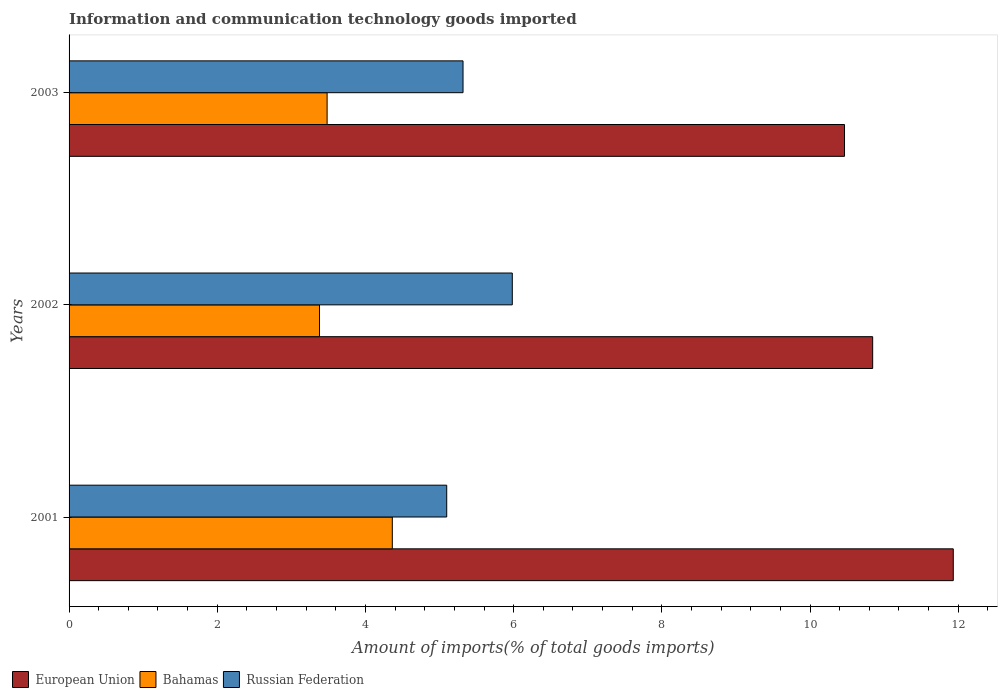How many different coloured bars are there?
Offer a terse response. 3. Are the number of bars on each tick of the Y-axis equal?
Ensure brevity in your answer.  Yes. How many bars are there on the 3rd tick from the bottom?
Your response must be concise. 3. What is the label of the 3rd group of bars from the top?
Give a very brief answer. 2001. What is the amount of goods imported in Bahamas in 2002?
Your answer should be very brief. 3.38. Across all years, what is the maximum amount of goods imported in Russian Federation?
Offer a very short reply. 5.98. Across all years, what is the minimum amount of goods imported in European Union?
Provide a short and direct response. 10.47. In which year was the amount of goods imported in Russian Federation maximum?
Your answer should be very brief. 2002. In which year was the amount of goods imported in Bahamas minimum?
Your answer should be very brief. 2002. What is the total amount of goods imported in European Union in the graph?
Your answer should be very brief. 33.25. What is the difference between the amount of goods imported in European Union in 2001 and that in 2002?
Your answer should be compact. 1.09. What is the difference between the amount of goods imported in European Union in 2001 and the amount of goods imported in Russian Federation in 2002?
Offer a very short reply. 5.95. What is the average amount of goods imported in European Union per year?
Offer a terse response. 11.08. In the year 2001, what is the difference between the amount of goods imported in European Union and amount of goods imported in Russian Federation?
Your answer should be compact. 6.84. What is the ratio of the amount of goods imported in Bahamas in 2002 to that in 2003?
Your response must be concise. 0.97. Is the amount of goods imported in Bahamas in 2001 less than that in 2003?
Give a very brief answer. No. What is the difference between the highest and the second highest amount of goods imported in Bahamas?
Your answer should be very brief. 0.88. What is the difference between the highest and the lowest amount of goods imported in Russian Federation?
Your answer should be compact. 0.89. Is the sum of the amount of goods imported in Bahamas in 2001 and 2003 greater than the maximum amount of goods imported in Russian Federation across all years?
Your answer should be very brief. Yes. What does the 1st bar from the top in 2003 represents?
Keep it short and to the point. Russian Federation. What does the 2nd bar from the bottom in 2003 represents?
Offer a very short reply. Bahamas. Is it the case that in every year, the sum of the amount of goods imported in Russian Federation and amount of goods imported in Bahamas is greater than the amount of goods imported in European Union?
Your response must be concise. No. Does the graph contain grids?
Ensure brevity in your answer.  No. Where does the legend appear in the graph?
Provide a succinct answer. Bottom left. How are the legend labels stacked?
Ensure brevity in your answer.  Horizontal. What is the title of the graph?
Provide a short and direct response. Information and communication technology goods imported. What is the label or title of the X-axis?
Ensure brevity in your answer.  Amount of imports(% of total goods imports). What is the label or title of the Y-axis?
Offer a terse response. Years. What is the Amount of imports(% of total goods imports) of European Union in 2001?
Your answer should be compact. 11.93. What is the Amount of imports(% of total goods imports) in Bahamas in 2001?
Your response must be concise. 4.36. What is the Amount of imports(% of total goods imports) of Russian Federation in 2001?
Provide a succinct answer. 5.1. What is the Amount of imports(% of total goods imports) in European Union in 2002?
Offer a terse response. 10.85. What is the Amount of imports(% of total goods imports) in Bahamas in 2002?
Your answer should be compact. 3.38. What is the Amount of imports(% of total goods imports) in Russian Federation in 2002?
Your answer should be compact. 5.98. What is the Amount of imports(% of total goods imports) of European Union in 2003?
Your response must be concise. 10.47. What is the Amount of imports(% of total goods imports) of Bahamas in 2003?
Offer a terse response. 3.48. What is the Amount of imports(% of total goods imports) in Russian Federation in 2003?
Your answer should be compact. 5.32. Across all years, what is the maximum Amount of imports(% of total goods imports) of European Union?
Your response must be concise. 11.93. Across all years, what is the maximum Amount of imports(% of total goods imports) in Bahamas?
Your response must be concise. 4.36. Across all years, what is the maximum Amount of imports(% of total goods imports) in Russian Federation?
Your response must be concise. 5.98. Across all years, what is the minimum Amount of imports(% of total goods imports) in European Union?
Offer a terse response. 10.47. Across all years, what is the minimum Amount of imports(% of total goods imports) in Bahamas?
Give a very brief answer. 3.38. Across all years, what is the minimum Amount of imports(% of total goods imports) in Russian Federation?
Offer a terse response. 5.1. What is the total Amount of imports(% of total goods imports) of European Union in the graph?
Provide a short and direct response. 33.25. What is the total Amount of imports(% of total goods imports) of Bahamas in the graph?
Ensure brevity in your answer.  11.23. What is the total Amount of imports(% of total goods imports) of Russian Federation in the graph?
Your response must be concise. 16.4. What is the difference between the Amount of imports(% of total goods imports) in European Union in 2001 and that in 2002?
Your answer should be compact. 1.09. What is the difference between the Amount of imports(% of total goods imports) of Bahamas in 2001 and that in 2002?
Ensure brevity in your answer.  0.98. What is the difference between the Amount of imports(% of total goods imports) in Russian Federation in 2001 and that in 2002?
Keep it short and to the point. -0.89. What is the difference between the Amount of imports(% of total goods imports) of European Union in 2001 and that in 2003?
Offer a terse response. 1.47. What is the difference between the Amount of imports(% of total goods imports) of Bahamas in 2001 and that in 2003?
Ensure brevity in your answer.  0.88. What is the difference between the Amount of imports(% of total goods imports) of Russian Federation in 2001 and that in 2003?
Your answer should be compact. -0.22. What is the difference between the Amount of imports(% of total goods imports) of European Union in 2002 and that in 2003?
Your answer should be very brief. 0.38. What is the difference between the Amount of imports(% of total goods imports) in Bahamas in 2002 and that in 2003?
Provide a short and direct response. -0.1. What is the difference between the Amount of imports(% of total goods imports) in Russian Federation in 2002 and that in 2003?
Give a very brief answer. 0.66. What is the difference between the Amount of imports(% of total goods imports) of European Union in 2001 and the Amount of imports(% of total goods imports) of Bahamas in 2002?
Your answer should be compact. 8.55. What is the difference between the Amount of imports(% of total goods imports) in European Union in 2001 and the Amount of imports(% of total goods imports) in Russian Federation in 2002?
Give a very brief answer. 5.95. What is the difference between the Amount of imports(% of total goods imports) of Bahamas in 2001 and the Amount of imports(% of total goods imports) of Russian Federation in 2002?
Offer a very short reply. -1.62. What is the difference between the Amount of imports(% of total goods imports) in European Union in 2001 and the Amount of imports(% of total goods imports) in Bahamas in 2003?
Keep it short and to the point. 8.45. What is the difference between the Amount of imports(% of total goods imports) in European Union in 2001 and the Amount of imports(% of total goods imports) in Russian Federation in 2003?
Provide a succinct answer. 6.62. What is the difference between the Amount of imports(% of total goods imports) in Bahamas in 2001 and the Amount of imports(% of total goods imports) in Russian Federation in 2003?
Keep it short and to the point. -0.95. What is the difference between the Amount of imports(% of total goods imports) of European Union in 2002 and the Amount of imports(% of total goods imports) of Bahamas in 2003?
Your response must be concise. 7.36. What is the difference between the Amount of imports(% of total goods imports) of European Union in 2002 and the Amount of imports(% of total goods imports) of Russian Federation in 2003?
Ensure brevity in your answer.  5.53. What is the difference between the Amount of imports(% of total goods imports) of Bahamas in 2002 and the Amount of imports(% of total goods imports) of Russian Federation in 2003?
Provide a succinct answer. -1.94. What is the average Amount of imports(% of total goods imports) in European Union per year?
Give a very brief answer. 11.08. What is the average Amount of imports(% of total goods imports) in Bahamas per year?
Provide a short and direct response. 3.74. What is the average Amount of imports(% of total goods imports) in Russian Federation per year?
Your response must be concise. 5.47. In the year 2001, what is the difference between the Amount of imports(% of total goods imports) of European Union and Amount of imports(% of total goods imports) of Bahamas?
Make the answer very short. 7.57. In the year 2001, what is the difference between the Amount of imports(% of total goods imports) of European Union and Amount of imports(% of total goods imports) of Russian Federation?
Your answer should be very brief. 6.84. In the year 2001, what is the difference between the Amount of imports(% of total goods imports) of Bahamas and Amount of imports(% of total goods imports) of Russian Federation?
Your answer should be compact. -0.73. In the year 2002, what is the difference between the Amount of imports(% of total goods imports) of European Union and Amount of imports(% of total goods imports) of Bahamas?
Offer a terse response. 7.47. In the year 2002, what is the difference between the Amount of imports(% of total goods imports) of European Union and Amount of imports(% of total goods imports) of Russian Federation?
Provide a succinct answer. 4.86. In the year 2002, what is the difference between the Amount of imports(% of total goods imports) of Bahamas and Amount of imports(% of total goods imports) of Russian Federation?
Provide a short and direct response. -2.6. In the year 2003, what is the difference between the Amount of imports(% of total goods imports) in European Union and Amount of imports(% of total goods imports) in Bahamas?
Offer a very short reply. 6.98. In the year 2003, what is the difference between the Amount of imports(% of total goods imports) in European Union and Amount of imports(% of total goods imports) in Russian Federation?
Provide a succinct answer. 5.15. In the year 2003, what is the difference between the Amount of imports(% of total goods imports) in Bahamas and Amount of imports(% of total goods imports) in Russian Federation?
Keep it short and to the point. -1.83. What is the ratio of the Amount of imports(% of total goods imports) in European Union in 2001 to that in 2002?
Give a very brief answer. 1.1. What is the ratio of the Amount of imports(% of total goods imports) of Bahamas in 2001 to that in 2002?
Your answer should be very brief. 1.29. What is the ratio of the Amount of imports(% of total goods imports) of Russian Federation in 2001 to that in 2002?
Offer a terse response. 0.85. What is the ratio of the Amount of imports(% of total goods imports) in European Union in 2001 to that in 2003?
Ensure brevity in your answer.  1.14. What is the ratio of the Amount of imports(% of total goods imports) in Bahamas in 2001 to that in 2003?
Offer a terse response. 1.25. What is the ratio of the Amount of imports(% of total goods imports) in Russian Federation in 2001 to that in 2003?
Your response must be concise. 0.96. What is the ratio of the Amount of imports(% of total goods imports) in European Union in 2002 to that in 2003?
Give a very brief answer. 1.04. What is the ratio of the Amount of imports(% of total goods imports) of Bahamas in 2002 to that in 2003?
Offer a terse response. 0.97. What is the difference between the highest and the second highest Amount of imports(% of total goods imports) in European Union?
Your response must be concise. 1.09. What is the difference between the highest and the second highest Amount of imports(% of total goods imports) of Bahamas?
Your answer should be very brief. 0.88. What is the difference between the highest and the second highest Amount of imports(% of total goods imports) in Russian Federation?
Keep it short and to the point. 0.66. What is the difference between the highest and the lowest Amount of imports(% of total goods imports) of European Union?
Make the answer very short. 1.47. What is the difference between the highest and the lowest Amount of imports(% of total goods imports) of Bahamas?
Your response must be concise. 0.98. What is the difference between the highest and the lowest Amount of imports(% of total goods imports) of Russian Federation?
Offer a terse response. 0.89. 